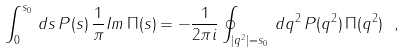<formula> <loc_0><loc_0><loc_500><loc_500>\int _ { 0 } ^ { s _ { 0 } } \, d s \, P ( s ) \, \frac { 1 } { \pi } { I m } \, \Pi ( s ) = - \frac { 1 } { 2 \pi i } \oint _ { | q ^ { 2 } | = s _ { 0 } } \, d q ^ { 2 } \, P ( q ^ { 2 } ) \, \Pi ( q ^ { 2 } ) \ ,</formula> 